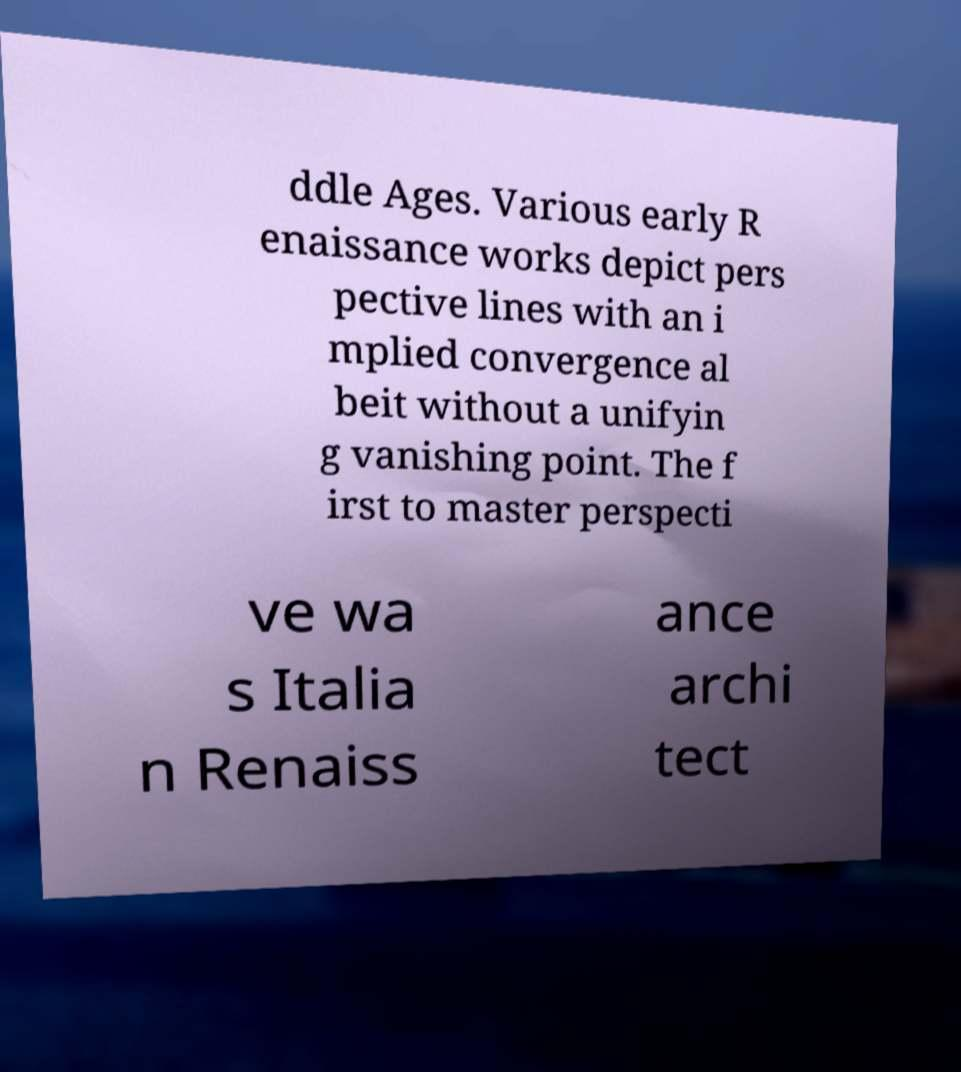Can you read and provide the text displayed in the image?This photo seems to have some interesting text. Can you extract and type it out for me? ddle Ages. Various early R enaissance works depict pers pective lines with an i mplied convergence al beit without a unifyin g vanishing point. The f irst to master perspecti ve wa s Italia n Renaiss ance archi tect 